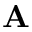<formula> <loc_0><loc_0><loc_500><loc_500>A</formula> 